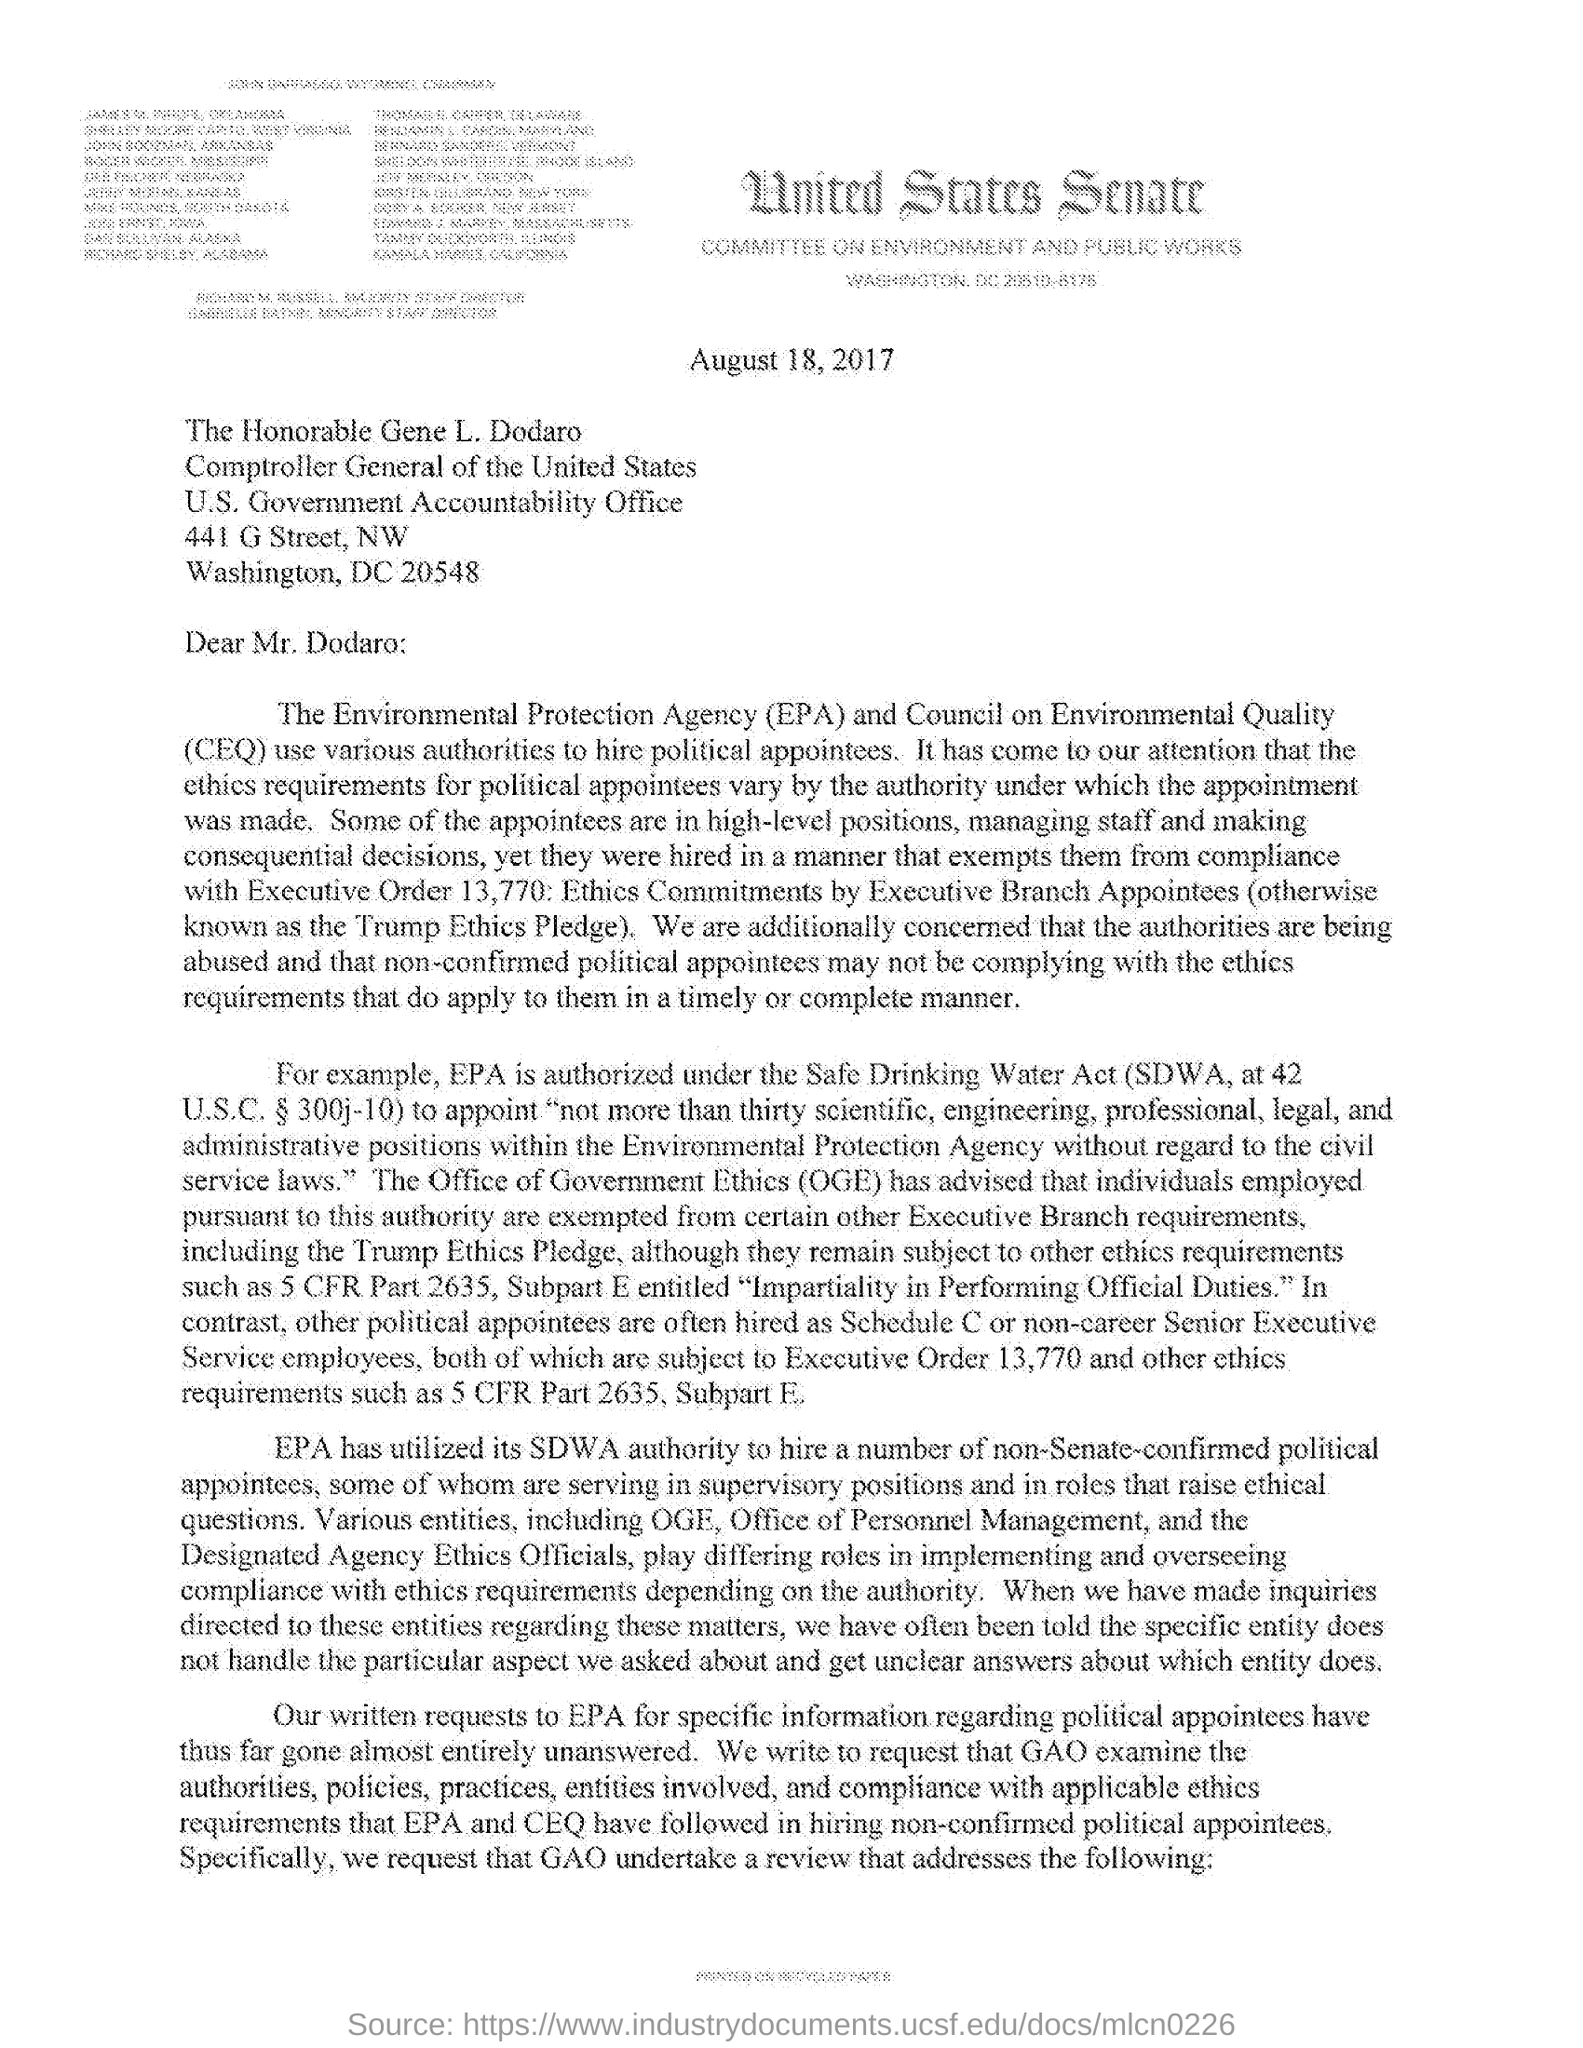What does CEQ stands for?
Keep it short and to the point. COUNCIL ON ENVIRONMENTAL QUALITY. What is the issued date of the letter?
Keep it short and to the point. AUGUST 18, 2017. Which authority is utilized by EPA to hire a number of non-Senate-confirmed political appointees?
Your answer should be very brief. SDWA authority. Who is the addressee of this letter?
Give a very brief answer. Mr. Dodaro. 